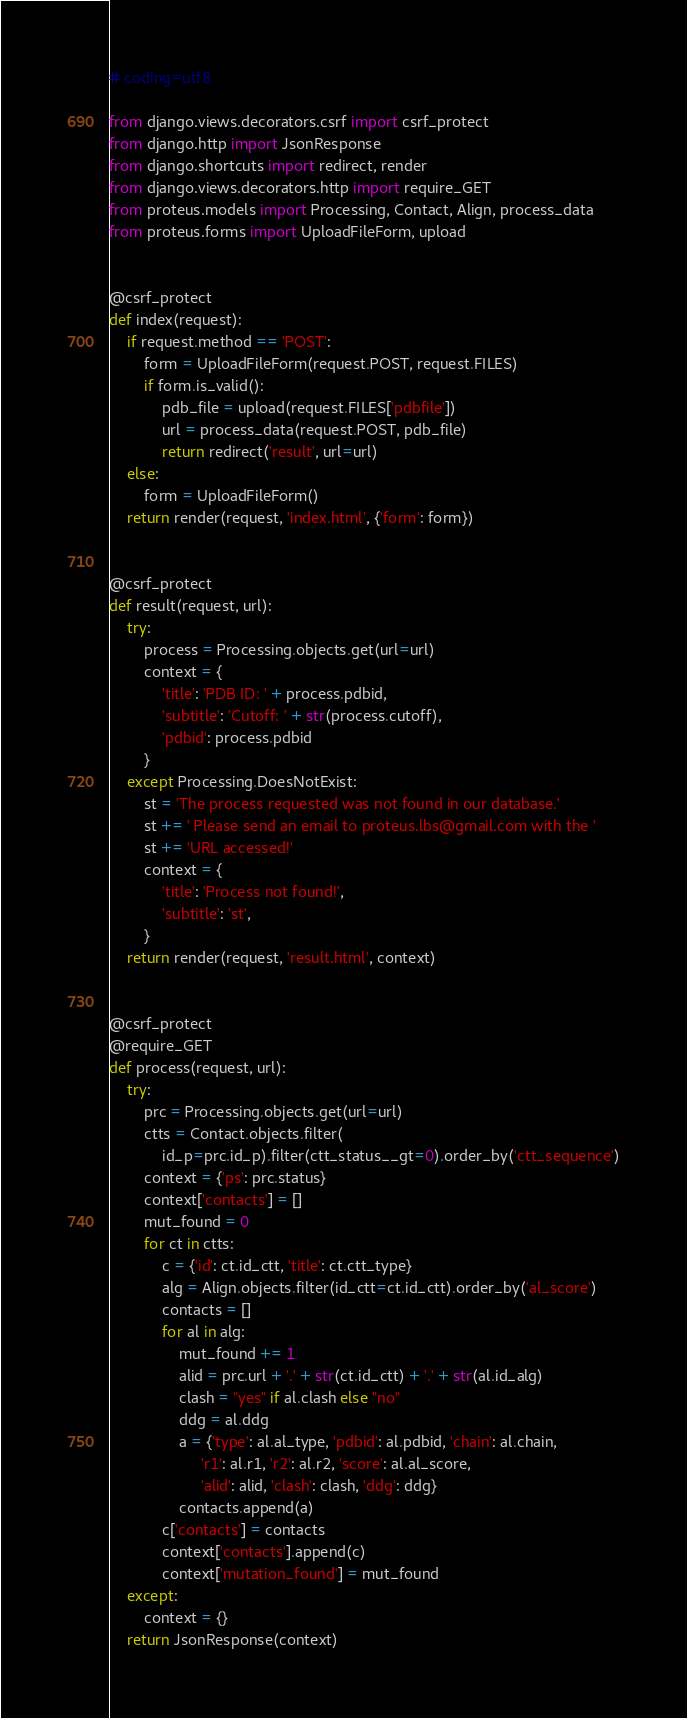Convert code to text. <code><loc_0><loc_0><loc_500><loc_500><_Python_># coding=utf8

from django.views.decorators.csrf import csrf_protect
from django.http import JsonResponse
from django.shortcuts import redirect, render
from django.views.decorators.http import require_GET
from proteus.models import Processing, Contact, Align, process_data
from proteus.forms import UploadFileForm, upload


@csrf_protect
def index(request):
    if request.method == 'POST':
        form = UploadFileForm(request.POST, request.FILES)
        if form.is_valid():
            pdb_file = upload(request.FILES['pdbfile'])
            url = process_data(request.POST, pdb_file)
            return redirect('result', url=url)
    else:
        form = UploadFileForm()
    return render(request, 'index.html', {'form': form})


@csrf_protect
def result(request, url):
    try:
        process = Processing.objects.get(url=url)
        context = {
            'title': 'PDB ID: ' + process.pdbid,
            'subtitle': 'Cutoff: ' + str(process.cutoff),
            'pdbid': process.pdbid
        }
    except Processing.DoesNotExist:
        st = 'The process requested was not found in our database.'
        st += ' Please send an email to proteus.lbs@gmail.com with the '
        st += 'URL accessed!'
        context = {
            'title': 'Process not found!',
            'subtitle': 'st',
        }
    return render(request, 'result.html', context)


@csrf_protect
@require_GET
def process(request, url):
    try:
        prc = Processing.objects.get(url=url)
        ctts = Contact.objects.filter(
            id_p=prc.id_p).filter(ctt_status__gt=0).order_by('ctt_sequence')
        context = {'ps': prc.status}
        context['contacts'] = []
        mut_found = 0
        for ct in ctts:
            c = {'id': ct.id_ctt, 'title': ct.ctt_type}
            alg = Align.objects.filter(id_ctt=ct.id_ctt).order_by('al_score')
            contacts = []
            for al in alg:
                mut_found += 1
                alid = prc.url + '.' + str(ct.id_ctt) + '.' + str(al.id_alg)
                clash = "yes" if al.clash else "no"
                ddg = al.ddg
                a = {'type': al.al_type, 'pdbid': al.pdbid, 'chain': al.chain,
                     'r1': al.r1, 'r2': al.r2, 'score': al.al_score,
                     'alid': alid, 'clash': clash, 'ddg': ddg}
                contacts.append(a)
            c['contacts'] = contacts
            context['contacts'].append(c)
            context['mutation_found'] = mut_found
    except:
        context = {}
    return JsonResponse(context)</code> 